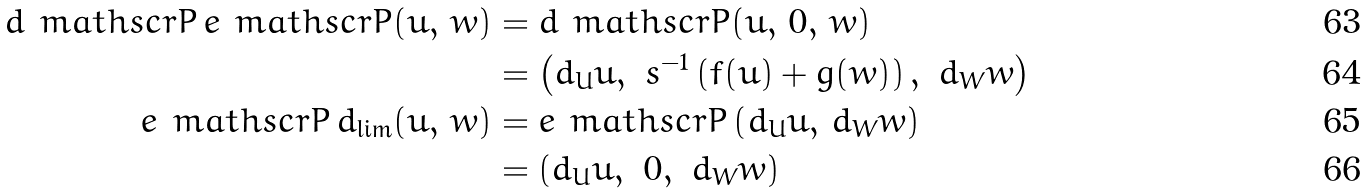Convert formula to latex. <formula><loc_0><loc_0><loc_500><loc_500>d _ { \ } m a t h s c r { P } \, e _ { \ } m a t h s c r { P } ( u , \, w ) & = d _ { \ } m a t h s c r { P } ( u , \, 0 , \, w ) \\ & = \left ( d _ { U } u , \ s ^ { - 1 } \left ( f ( u ) + g ( w ) \right ) , \ d _ { W } w \right ) \\ e _ { \ } m a t h s c r { P } \, d _ { \lim } ( u , \, w ) & = e _ { \ } m a t h s c r { P } \left ( d _ { U } u , \, d _ { W } w \right ) \\ & = \left ( d _ { U } u , \ 0 , \ d _ { W } w \right )</formula> 